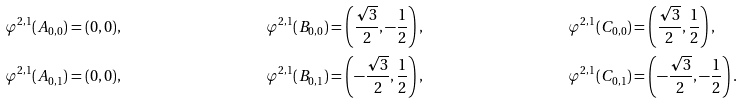Convert formula to latex. <formula><loc_0><loc_0><loc_500><loc_500>\varphi ^ { 2 , 1 } ( A _ { 0 , 0 } ) & = ( 0 , 0 ) , & \varphi ^ { 2 , 1 } ( B _ { 0 , 0 } ) & = \left ( \frac { \sqrt { 3 } } { 2 } , - \frac { 1 } { 2 } \right ) , & \varphi ^ { 2 , 1 } ( C _ { 0 , 0 } ) & = \left ( \frac { \sqrt { 3 } } { 2 } , \frac { 1 } { 2 } \right ) , \\ \varphi ^ { 2 , 1 } ( A _ { 0 , 1 } ) & = ( 0 , 0 ) , & \varphi ^ { 2 , 1 } ( B _ { 0 , 1 } ) & = \left ( - \frac { \sqrt { 3 } } { 2 } , \frac { 1 } { 2 } \right ) , & \varphi ^ { 2 , 1 } ( C _ { 0 , 1 } ) & = \left ( - \frac { \sqrt { 3 } } { 2 } , - \frac { 1 } { 2 } \right ) .</formula> 